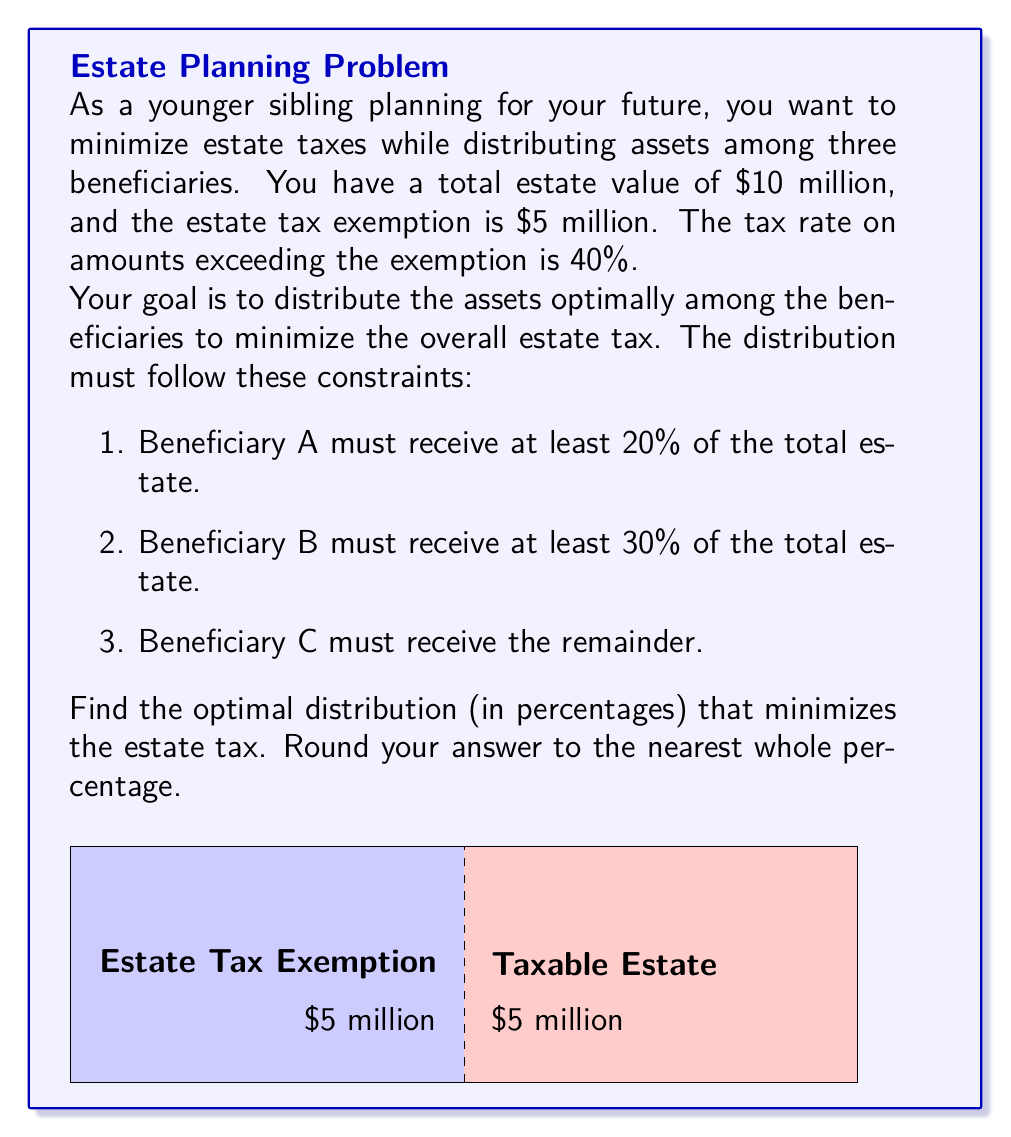Solve this math problem. Let's approach this step-by-step:

1) First, we need to understand that any amount over $5 million will be taxed at 40%.

2) The goal is to minimize the taxable amount, which is $5 million (total estate - exemption).

3) To minimize taxes, we should aim to distribute exactly $5 million to one or more beneficiaries who can claim the exemption.

4) Let's define variables:
   $x$ = percentage for Beneficiary A
   $y$ = percentage for Beneficiary B
   $z$ = percentage for Beneficiary C

5) We have the following constraints:
   $x \geq 20\%$
   $y \geq 30\%$
   $x + y + z = 100\%$

6) The optimal solution is to allocate 50% ($5 million) to one beneficiary and split the remaining 50% between the other two while satisfying the constraints.

7) The most efficient distribution that satisfies all constraints is:
   Beneficiary A: 20%
   Beneficiary B: 30%
   Beneficiary C: 50%

8) With this distribution:
   - Beneficiary C receives $5 million, which is tax-free.
   - Beneficiaries A and B receive a total of $5 million, which is fully taxable.

9) The estate tax would be:
   $\text{Tax} = 40\% \times \$5\text{ million} = \$2\text{ million}$

This is the minimum possible tax given the constraints.
Answer: 20%, 30%, 50% 